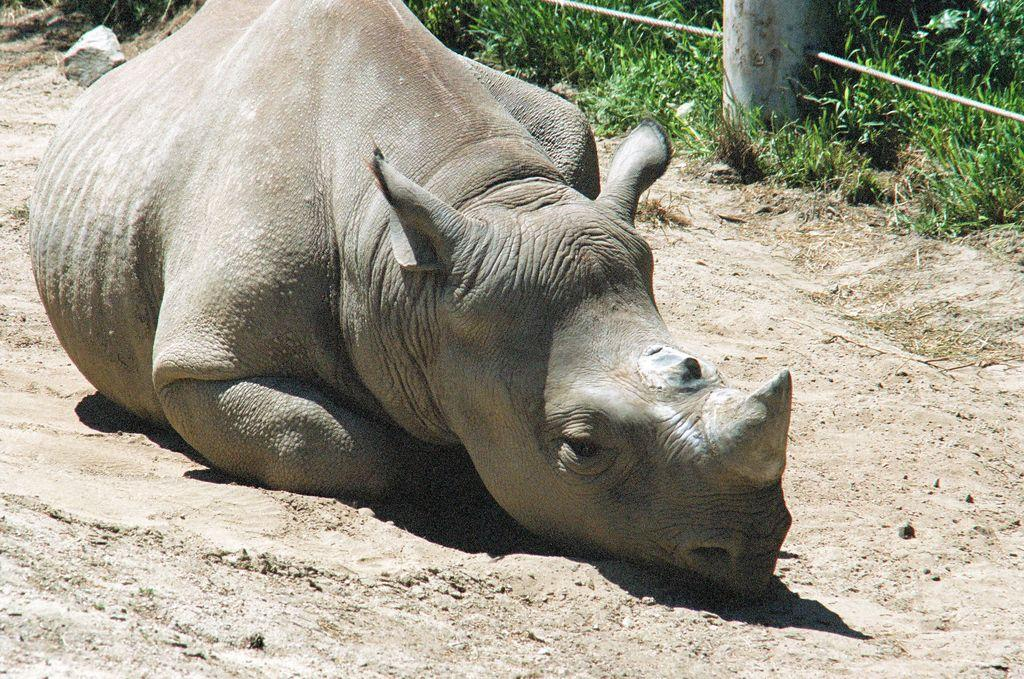What type of animal can be seen on the ground in the image? There is an animal on the ground in the image, but the specific type is not mentioned. What can be seen in the background of the image? In the background of the image, there is grass, a stone, a rope, and an unspecified object. Can you describe the vegetation in the image? The vegetation in the image consists of grass in the background. What type of juice is being served in the park with the sister in the image? There is no mention of juice, a park, or a sister in the image. The image only contains an animal on the ground and various objects in the background. 